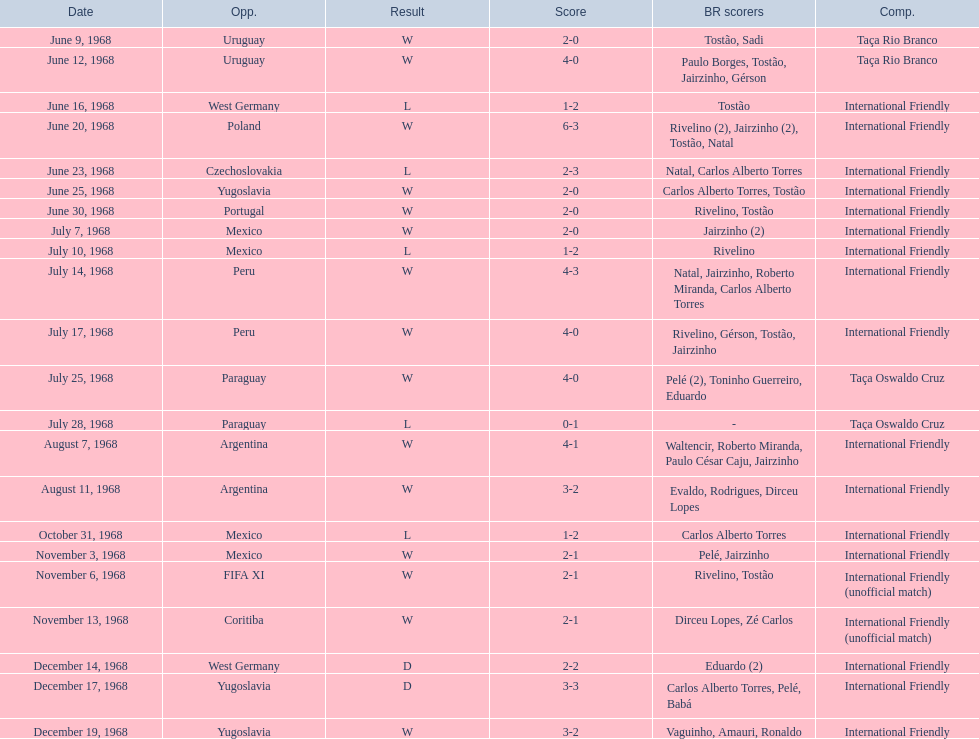What is the total count of losses? 5. 